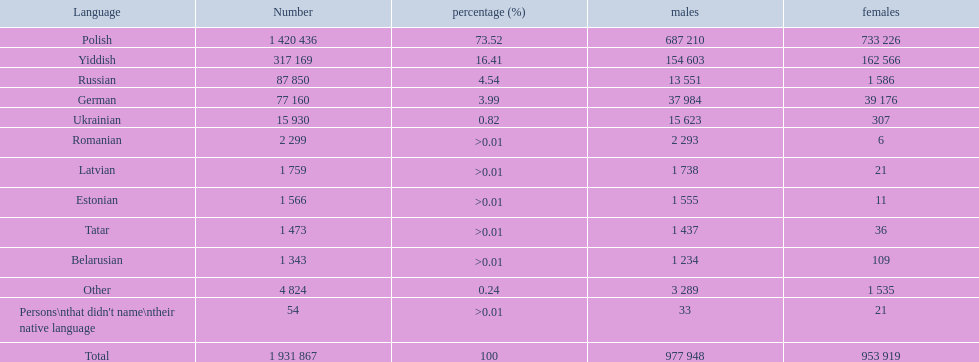What identified local languages spoken in the warsaw governorate have more males than females? Russian, Ukrainian, Romanian, Latvian, Estonian, Tatar, Belarusian. Help me parse the entirety of this table. {'header': ['Language', 'Number', 'percentage (%)', 'males', 'females'], 'rows': [['Polish', '1 420 436', '73.52', '687 210', '733 226'], ['Yiddish', '317 169', '16.41', '154 603', '162 566'], ['Russian', '87 850', '4.54', '13 551', '1 586'], ['German', '77 160', '3.99', '37 984', '39 176'], ['Ukrainian', '15 930', '0.82', '15 623', '307'], ['Romanian', '2 299', '>0.01', '2 293', '6'], ['Latvian', '1 759', '>0.01', '1 738', '21'], ['Estonian', '1 566', '>0.01', '1 555', '11'], ['Tatar', '1 473', '>0.01', '1 437', '36'], ['Belarusian', '1 343', '>0.01', '1 234', '109'], ['Other', '4 824', '0.24', '3 289', '1 535'], ["Persons\\nthat didn't name\\ntheir native language", '54', '>0.01', '33', '21'], ['Total', '1 931 867', '100', '977 948', '953 919']]} Which of those have under 500 males listed? Romanian, Latvian, Estonian, Tatar, Belarusian. Of the remaining languages, which of them have under 20 females? Romanian, Estonian. Which of these has the highest overall number listed? Romanian. 